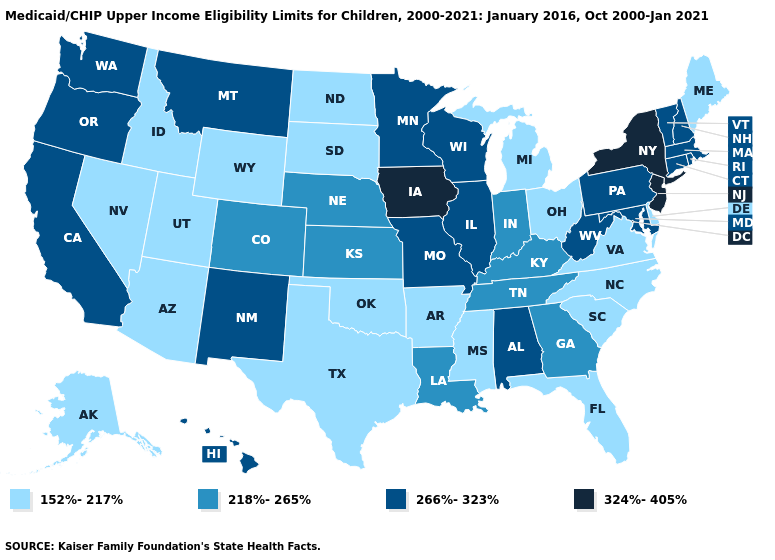Among the states that border Arizona , which have the highest value?
Concise answer only. California, New Mexico. What is the lowest value in states that border Massachusetts?
Write a very short answer. 266%-323%. What is the lowest value in the USA?
Write a very short answer. 152%-217%. Does Missouri have a higher value than South Dakota?
Quick response, please. Yes. What is the value of Arkansas?
Keep it brief. 152%-217%. What is the value of Maryland?
Quick response, please. 266%-323%. What is the lowest value in the USA?
Be succinct. 152%-217%. What is the highest value in the MidWest ?
Be succinct. 324%-405%. Name the states that have a value in the range 324%-405%?
Be succinct. Iowa, New Jersey, New York. What is the highest value in the USA?
Give a very brief answer. 324%-405%. What is the value of Nevada?
Answer briefly. 152%-217%. Among the states that border West Virginia , does Ohio have the highest value?
Answer briefly. No. What is the lowest value in the West?
Write a very short answer. 152%-217%. What is the highest value in states that border Nebraska?
Concise answer only. 324%-405%. Does Maine have the lowest value in the Northeast?
Give a very brief answer. Yes. 